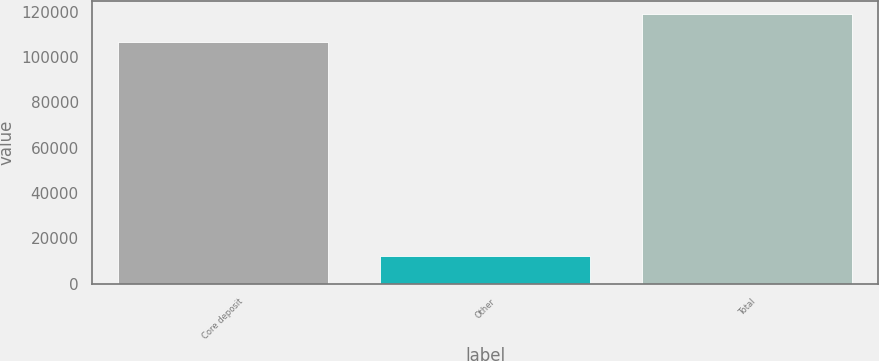<chart> <loc_0><loc_0><loc_500><loc_500><bar_chart><fcel>Core deposit<fcel>Other<fcel>Total<nl><fcel>106688<fcel>12102<fcel>118790<nl></chart> 